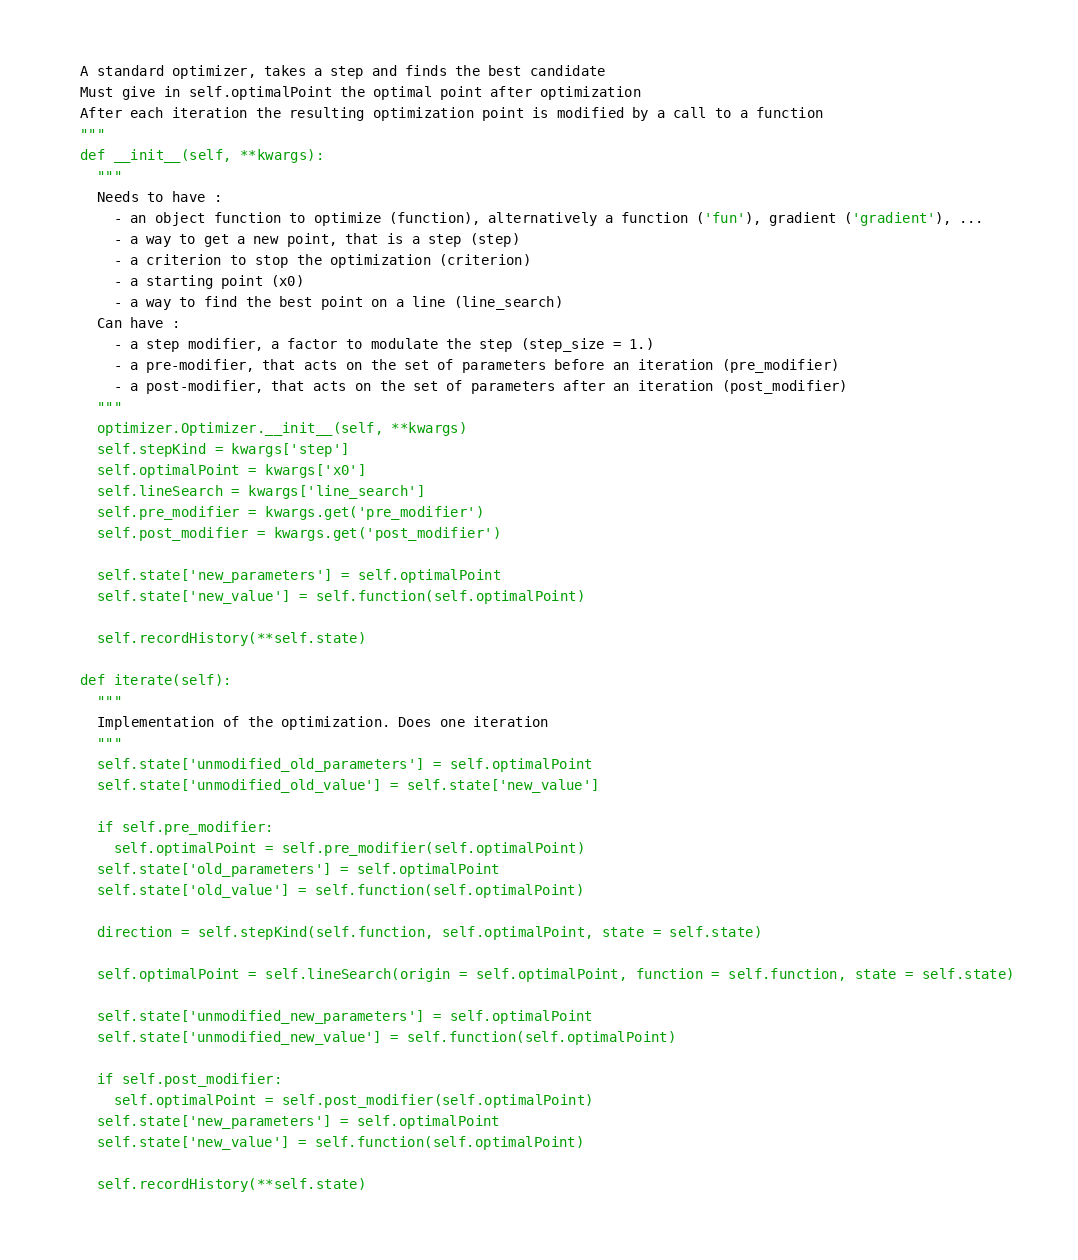<code> <loc_0><loc_0><loc_500><loc_500><_Python_>  A standard optimizer, takes a step and finds the best candidate
  Must give in self.optimalPoint the optimal point after optimization
  After each iteration the resulting optimization point is modified by a call to a function
  """
  def __init__(self, **kwargs):
    """
    Needs to have :
      - an object function to optimize (function), alternatively a function ('fun'), gradient ('gradient'), ...
      - a way to get a new point, that is a step (step)
      - a criterion to stop the optimization (criterion)
      - a starting point (x0)
      - a way to find the best point on a line (line_search)
    Can have :
      - a step modifier, a factor to modulate the step (step_size = 1.)
      - a pre-modifier, that acts on the set of parameters before an iteration (pre_modifier)
      - a post-modifier, that acts on the set of parameters after an iteration (post_modifier)
    """
    optimizer.Optimizer.__init__(self, **kwargs)
    self.stepKind = kwargs['step']
    self.optimalPoint = kwargs['x0']
    self.lineSearch = kwargs['line_search']
    self.pre_modifier = kwargs.get('pre_modifier')
    self.post_modifier = kwargs.get('post_modifier')

    self.state['new_parameters'] = self.optimalPoint
    self.state['new_value'] = self.function(self.optimalPoint)

    self.recordHistory(**self.state)

  def iterate(self):
    """
    Implementation of the optimization. Does one iteration
    """
    self.state['unmodified_old_parameters'] = self.optimalPoint
    self.state['unmodified_old_value'] = self.state['new_value']

    if self.pre_modifier:
      self.optimalPoint = self.pre_modifier(self.optimalPoint)
    self.state['old_parameters'] = self.optimalPoint
    self.state['old_value'] = self.function(self.optimalPoint)

    direction = self.stepKind(self.function, self.optimalPoint, state = self.state)

    self.optimalPoint = self.lineSearch(origin = self.optimalPoint, function = self.function, state = self.state)

    self.state['unmodified_new_parameters'] = self.optimalPoint
    self.state['unmodified_new_value'] = self.function(self.optimalPoint)

    if self.post_modifier:
      self.optimalPoint = self.post_modifier(self.optimalPoint)
    self.state['new_parameters'] = self.optimalPoint
    self.state['new_value'] = self.function(self.optimalPoint)

    self.recordHistory(**self.state)

</code> 